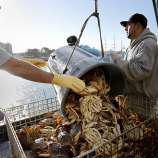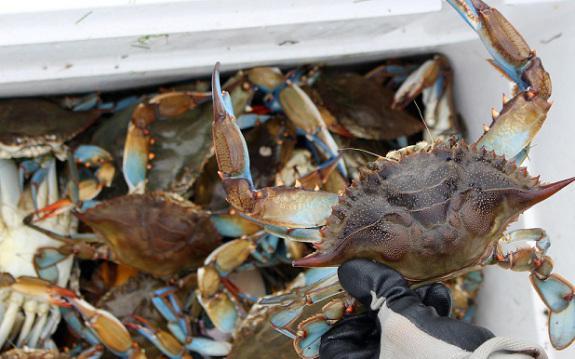The first image is the image on the left, the second image is the image on the right. Assess this claim about the two images: "Crabs are being dumped out of a container.". Correct or not? Answer yes or no. Yes. The first image is the image on the left, the second image is the image on the right. For the images displayed, is the sentence "In at least one image, the crabs have a blue tint near the claws." factually correct? Answer yes or no. Yes. 